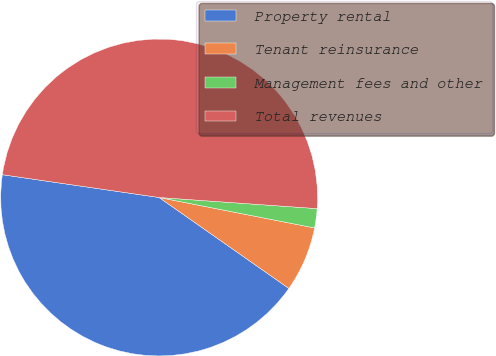Convert chart. <chart><loc_0><loc_0><loc_500><loc_500><pie_chart><fcel>Property rental<fcel>Tenant reinsurance<fcel>Management fees and other<fcel>Total revenues<nl><fcel>42.57%<fcel>6.65%<fcel>1.96%<fcel>48.82%<nl></chart> 